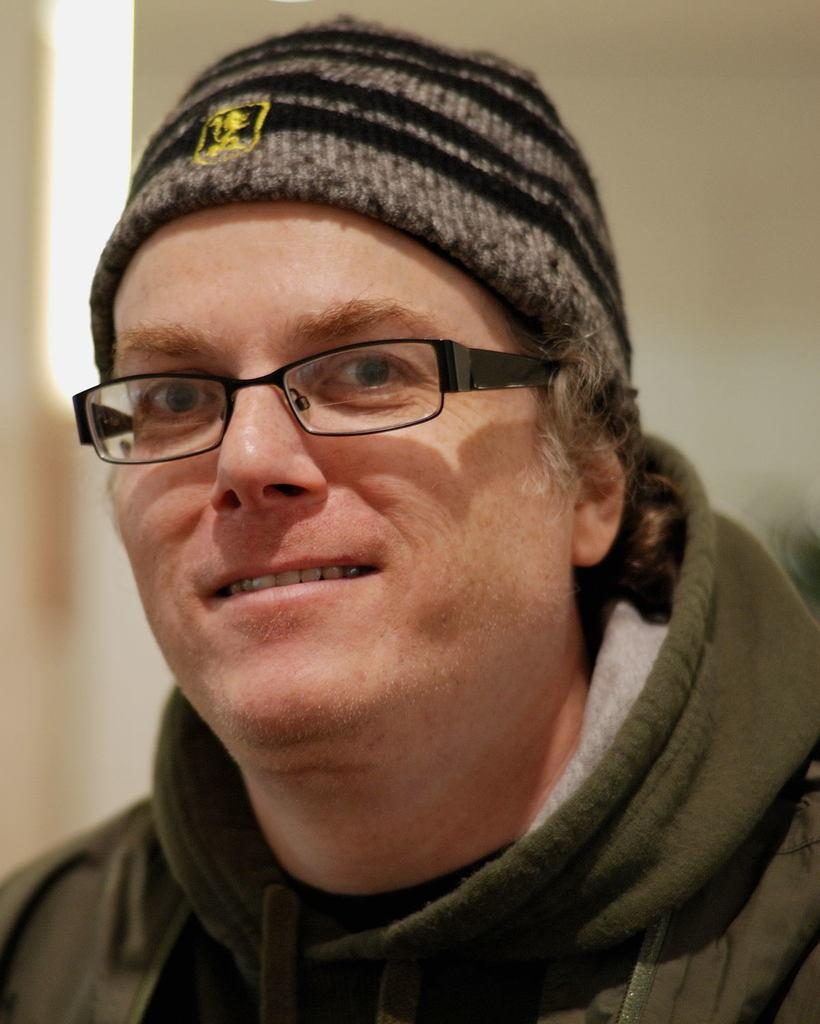Who is present in the image? There is a man in the image. What is the man wearing in the image? The man is wearing a green jacket. What can be seen in the background of the image? There is a wall visible in the background of the image. What type of yam is the man holding in the image? There is no yam present in the image; the man is not holding any yam. 